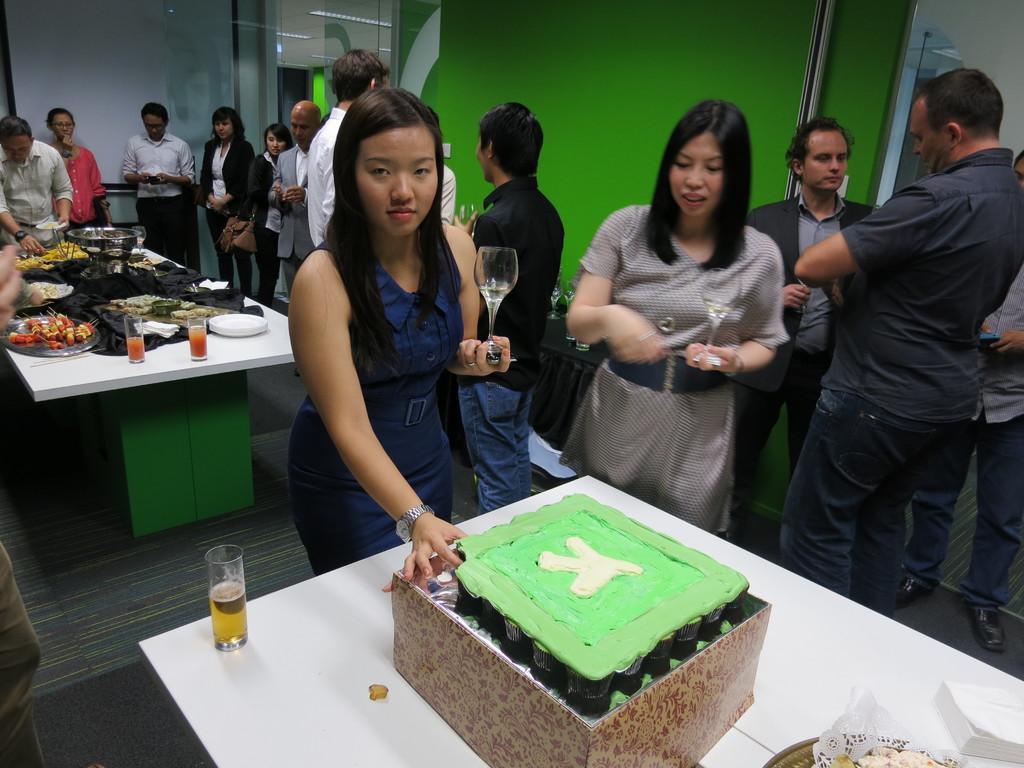Can you describe this image briefly? In the image we can see there are people who are standing and there is a cake on the table. 